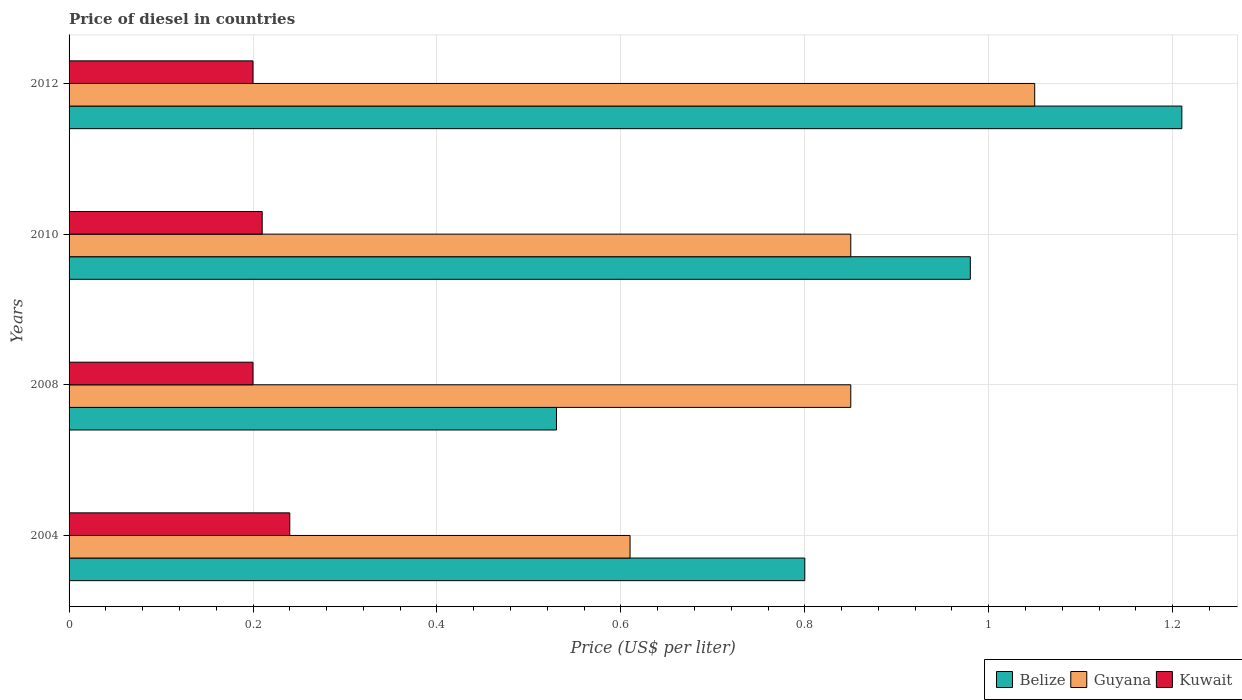How many different coloured bars are there?
Your response must be concise. 3. How many groups of bars are there?
Offer a very short reply. 4. Are the number of bars on each tick of the Y-axis equal?
Offer a very short reply. Yes. How many bars are there on the 4th tick from the top?
Your response must be concise. 3. What is the label of the 4th group of bars from the top?
Provide a succinct answer. 2004. In how many cases, is the number of bars for a given year not equal to the number of legend labels?
Your response must be concise. 0. Across all years, what is the maximum price of diesel in Kuwait?
Make the answer very short. 0.24. Across all years, what is the minimum price of diesel in Belize?
Provide a succinct answer. 0.53. In which year was the price of diesel in Belize maximum?
Your answer should be very brief. 2012. In which year was the price of diesel in Guyana minimum?
Give a very brief answer. 2004. What is the total price of diesel in Guyana in the graph?
Keep it short and to the point. 3.36. What is the difference between the price of diesel in Belize in 2008 and that in 2012?
Your answer should be very brief. -0.68. What is the difference between the price of diesel in Belize in 2010 and the price of diesel in Guyana in 2012?
Make the answer very short. -0.07. What is the average price of diesel in Belize per year?
Provide a short and direct response. 0.88. In the year 2004, what is the difference between the price of diesel in Guyana and price of diesel in Kuwait?
Your answer should be compact. 0.37. In how many years, is the price of diesel in Belize greater than 0.24000000000000002 US$?
Keep it short and to the point. 4. What is the ratio of the price of diesel in Guyana in 2008 to that in 2012?
Ensure brevity in your answer.  0.81. Is the price of diesel in Guyana in 2008 less than that in 2012?
Ensure brevity in your answer.  Yes. What is the difference between the highest and the second highest price of diesel in Belize?
Ensure brevity in your answer.  0.23. What is the difference between the highest and the lowest price of diesel in Kuwait?
Your answer should be very brief. 0.04. What does the 2nd bar from the top in 2012 represents?
Give a very brief answer. Guyana. What does the 3rd bar from the bottom in 2010 represents?
Your answer should be compact. Kuwait. Is it the case that in every year, the sum of the price of diesel in Kuwait and price of diesel in Guyana is greater than the price of diesel in Belize?
Offer a terse response. Yes. How many bars are there?
Your answer should be very brief. 12. Does the graph contain any zero values?
Make the answer very short. No. What is the title of the graph?
Offer a very short reply. Price of diesel in countries. What is the label or title of the X-axis?
Ensure brevity in your answer.  Price (US$ per liter). What is the Price (US$ per liter) of Guyana in 2004?
Keep it short and to the point. 0.61. What is the Price (US$ per liter) of Kuwait in 2004?
Your answer should be compact. 0.24. What is the Price (US$ per liter) in Belize in 2008?
Make the answer very short. 0.53. What is the Price (US$ per liter) of Guyana in 2008?
Make the answer very short. 0.85. What is the Price (US$ per liter) in Kuwait in 2008?
Offer a very short reply. 0.2. What is the Price (US$ per liter) of Guyana in 2010?
Make the answer very short. 0.85. What is the Price (US$ per liter) in Kuwait in 2010?
Offer a terse response. 0.21. What is the Price (US$ per liter) of Belize in 2012?
Your response must be concise. 1.21. What is the Price (US$ per liter) of Guyana in 2012?
Offer a terse response. 1.05. Across all years, what is the maximum Price (US$ per liter) in Belize?
Make the answer very short. 1.21. Across all years, what is the maximum Price (US$ per liter) in Guyana?
Your answer should be compact. 1.05. Across all years, what is the maximum Price (US$ per liter) of Kuwait?
Provide a short and direct response. 0.24. Across all years, what is the minimum Price (US$ per liter) of Belize?
Your answer should be compact. 0.53. Across all years, what is the minimum Price (US$ per liter) in Guyana?
Provide a succinct answer. 0.61. Across all years, what is the minimum Price (US$ per liter) of Kuwait?
Your answer should be very brief. 0.2. What is the total Price (US$ per liter) of Belize in the graph?
Ensure brevity in your answer.  3.52. What is the total Price (US$ per liter) in Guyana in the graph?
Offer a terse response. 3.36. What is the difference between the Price (US$ per liter) in Belize in 2004 and that in 2008?
Keep it short and to the point. 0.27. What is the difference between the Price (US$ per liter) of Guyana in 2004 and that in 2008?
Provide a short and direct response. -0.24. What is the difference between the Price (US$ per liter) in Belize in 2004 and that in 2010?
Offer a very short reply. -0.18. What is the difference between the Price (US$ per liter) in Guyana in 2004 and that in 2010?
Provide a short and direct response. -0.24. What is the difference between the Price (US$ per liter) in Kuwait in 2004 and that in 2010?
Your response must be concise. 0.03. What is the difference between the Price (US$ per liter) of Belize in 2004 and that in 2012?
Offer a terse response. -0.41. What is the difference between the Price (US$ per liter) of Guyana in 2004 and that in 2012?
Provide a succinct answer. -0.44. What is the difference between the Price (US$ per liter) of Kuwait in 2004 and that in 2012?
Give a very brief answer. 0.04. What is the difference between the Price (US$ per liter) in Belize in 2008 and that in 2010?
Your response must be concise. -0.45. What is the difference between the Price (US$ per liter) in Kuwait in 2008 and that in 2010?
Provide a short and direct response. -0.01. What is the difference between the Price (US$ per liter) of Belize in 2008 and that in 2012?
Provide a short and direct response. -0.68. What is the difference between the Price (US$ per liter) in Belize in 2010 and that in 2012?
Your answer should be very brief. -0.23. What is the difference between the Price (US$ per liter) in Belize in 2004 and the Price (US$ per liter) in Kuwait in 2008?
Your answer should be very brief. 0.6. What is the difference between the Price (US$ per liter) of Guyana in 2004 and the Price (US$ per liter) of Kuwait in 2008?
Your response must be concise. 0.41. What is the difference between the Price (US$ per liter) in Belize in 2004 and the Price (US$ per liter) in Kuwait in 2010?
Provide a succinct answer. 0.59. What is the difference between the Price (US$ per liter) of Guyana in 2004 and the Price (US$ per liter) of Kuwait in 2010?
Give a very brief answer. 0.4. What is the difference between the Price (US$ per liter) in Belize in 2004 and the Price (US$ per liter) in Kuwait in 2012?
Make the answer very short. 0.6. What is the difference between the Price (US$ per liter) in Guyana in 2004 and the Price (US$ per liter) in Kuwait in 2012?
Your answer should be very brief. 0.41. What is the difference between the Price (US$ per liter) in Belize in 2008 and the Price (US$ per liter) in Guyana in 2010?
Offer a very short reply. -0.32. What is the difference between the Price (US$ per liter) in Belize in 2008 and the Price (US$ per liter) in Kuwait in 2010?
Ensure brevity in your answer.  0.32. What is the difference between the Price (US$ per liter) in Guyana in 2008 and the Price (US$ per liter) in Kuwait in 2010?
Keep it short and to the point. 0.64. What is the difference between the Price (US$ per liter) in Belize in 2008 and the Price (US$ per liter) in Guyana in 2012?
Keep it short and to the point. -0.52. What is the difference between the Price (US$ per liter) of Belize in 2008 and the Price (US$ per liter) of Kuwait in 2012?
Provide a short and direct response. 0.33. What is the difference between the Price (US$ per liter) of Guyana in 2008 and the Price (US$ per liter) of Kuwait in 2012?
Your response must be concise. 0.65. What is the difference between the Price (US$ per liter) in Belize in 2010 and the Price (US$ per liter) in Guyana in 2012?
Offer a very short reply. -0.07. What is the difference between the Price (US$ per liter) in Belize in 2010 and the Price (US$ per liter) in Kuwait in 2012?
Keep it short and to the point. 0.78. What is the difference between the Price (US$ per liter) in Guyana in 2010 and the Price (US$ per liter) in Kuwait in 2012?
Your answer should be very brief. 0.65. What is the average Price (US$ per liter) in Guyana per year?
Provide a short and direct response. 0.84. What is the average Price (US$ per liter) in Kuwait per year?
Offer a terse response. 0.21. In the year 2004, what is the difference between the Price (US$ per liter) of Belize and Price (US$ per liter) of Guyana?
Offer a very short reply. 0.19. In the year 2004, what is the difference between the Price (US$ per liter) of Belize and Price (US$ per liter) of Kuwait?
Ensure brevity in your answer.  0.56. In the year 2004, what is the difference between the Price (US$ per liter) of Guyana and Price (US$ per liter) of Kuwait?
Provide a succinct answer. 0.37. In the year 2008, what is the difference between the Price (US$ per liter) of Belize and Price (US$ per liter) of Guyana?
Your answer should be very brief. -0.32. In the year 2008, what is the difference between the Price (US$ per liter) in Belize and Price (US$ per liter) in Kuwait?
Offer a very short reply. 0.33. In the year 2008, what is the difference between the Price (US$ per liter) of Guyana and Price (US$ per liter) of Kuwait?
Make the answer very short. 0.65. In the year 2010, what is the difference between the Price (US$ per liter) in Belize and Price (US$ per liter) in Guyana?
Your answer should be very brief. 0.13. In the year 2010, what is the difference between the Price (US$ per liter) in Belize and Price (US$ per liter) in Kuwait?
Make the answer very short. 0.77. In the year 2010, what is the difference between the Price (US$ per liter) in Guyana and Price (US$ per liter) in Kuwait?
Provide a short and direct response. 0.64. In the year 2012, what is the difference between the Price (US$ per liter) of Belize and Price (US$ per liter) of Guyana?
Your answer should be very brief. 0.16. What is the ratio of the Price (US$ per liter) of Belize in 2004 to that in 2008?
Make the answer very short. 1.51. What is the ratio of the Price (US$ per liter) in Guyana in 2004 to that in 2008?
Ensure brevity in your answer.  0.72. What is the ratio of the Price (US$ per liter) in Kuwait in 2004 to that in 2008?
Offer a terse response. 1.2. What is the ratio of the Price (US$ per liter) of Belize in 2004 to that in 2010?
Ensure brevity in your answer.  0.82. What is the ratio of the Price (US$ per liter) in Guyana in 2004 to that in 2010?
Your answer should be compact. 0.72. What is the ratio of the Price (US$ per liter) in Belize in 2004 to that in 2012?
Ensure brevity in your answer.  0.66. What is the ratio of the Price (US$ per liter) in Guyana in 2004 to that in 2012?
Your answer should be very brief. 0.58. What is the ratio of the Price (US$ per liter) of Kuwait in 2004 to that in 2012?
Offer a very short reply. 1.2. What is the ratio of the Price (US$ per liter) of Belize in 2008 to that in 2010?
Your answer should be compact. 0.54. What is the ratio of the Price (US$ per liter) in Kuwait in 2008 to that in 2010?
Offer a terse response. 0.95. What is the ratio of the Price (US$ per liter) of Belize in 2008 to that in 2012?
Offer a terse response. 0.44. What is the ratio of the Price (US$ per liter) in Guyana in 2008 to that in 2012?
Provide a succinct answer. 0.81. What is the ratio of the Price (US$ per liter) of Kuwait in 2008 to that in 2012?
Make the answer very short. 1. What is the ratio of the Price (US$ per liter) of Belize in 2010 to that in 2012?
Provide a succinct answer. 0.81. What is the ratio of the Price (US$ per liter) of Guyana in 2010 to that in 2012?
Your answer should be compact. 0.81. What is the ratio of the Price (US$ per liter) in Kuwait in 2010 to that in 2012?
Your response must be concise. 1.05. What is the difference between the highest and the second highest Price (US$ per liter) of Belize?
Offer a very short reply. 0.23. What is the difference between the highest and the second highest Price (US$ per liter) in Guyana?
Offer a terse response. 0.2. What is the difference between the highest and the lowest Price (US$ per liter) in Belize?
Provide a succinct answer. 0.68. What is the difference between the highest and the lowest Price (US$ per liter) of Guyana?
Offer a terse response. 0.44. 